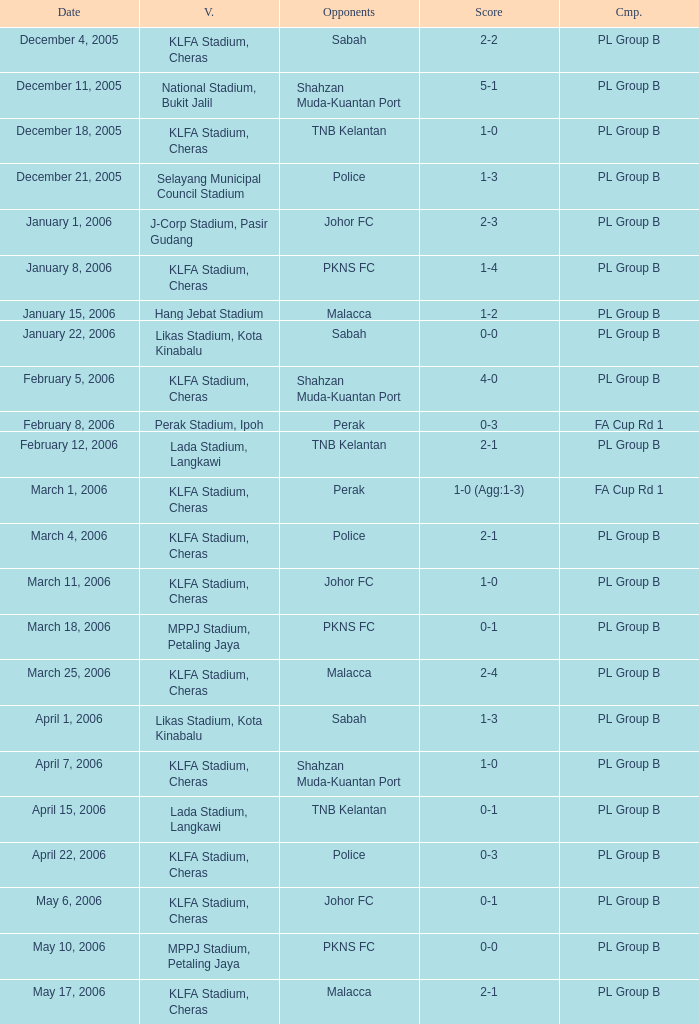Which Competition has a Score of 0-1, and Opponents of pkns fc? PL Group B. 